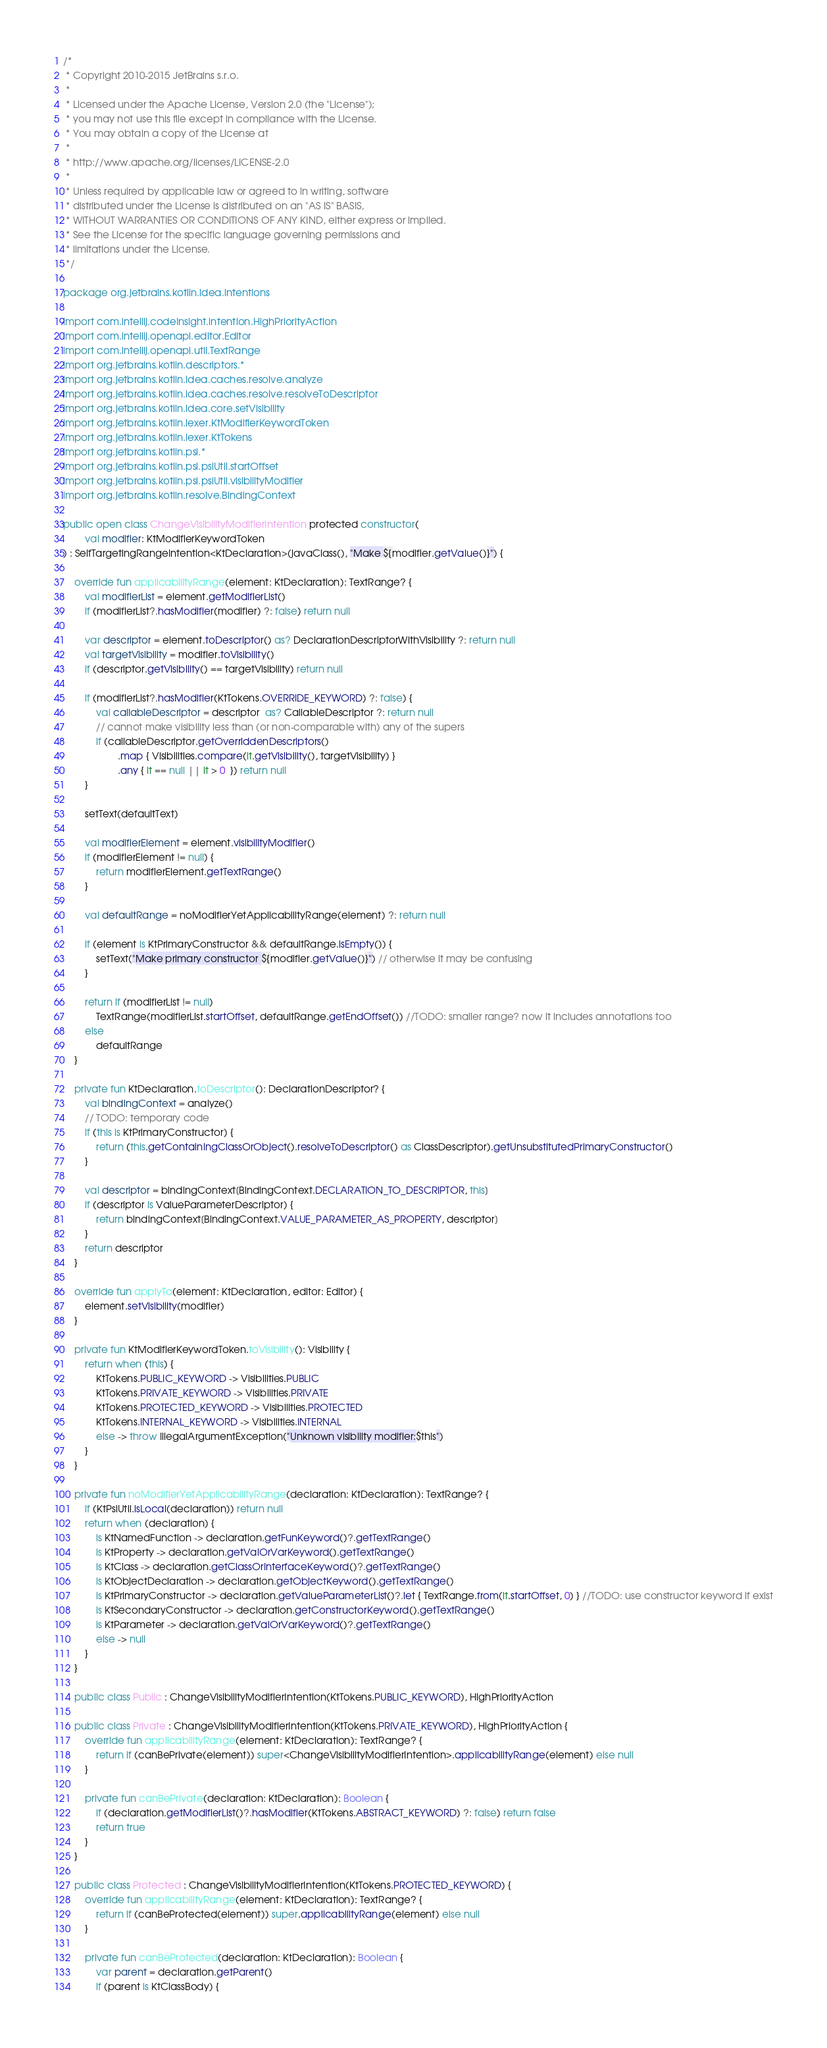Convert code to text. <code><loc_0><loc_0><loc_500><loc_500><_Kotlin_>/*
 * Copyright 2010-2015 JetBrains s.r.o.
 *
 * Licensed under the Apache License, Version 2.0 (the "License");
 * you may not use this file except in compliance with the License.
 * You may obtain a copy of the License at
 *
 * http://www.apache.org/licenses/LICENSE-2.0
 *
 * Unless required by applicable law or agreed to in writing, software
 * distributed under the License is distributed on an "AS IS" BASIS,
 * WITHOUT WARRANTIES OR CONDITIONS OF ANY KIND, either express or implied.
 * See the License for the specific language governing permissions and
 * limitations under the License.
 */

package org.jetbrains.kotlin.idea.intentions

import com.intellij.codeInsight.intention.HighPriorityAction
import com.intellij.openapi.editor.Editor
import com.intellij.openapi.util.TextRange
import org.jetbrains.kotlin.descriptors.*
import org.jetbrains.kotlin.idea.caches.resolve.analyze
import org.jetbrains.kotlin.idea.caches.resolve.resolveToDescriptor
import org.jetbrains.kotlin.idea.core.setVisibility
import org.jetbrains.kotlin.lexer.KtModifierKeywordToken
import org.jetbrains.kotlin.lexer.KtTokens
import org.jetbrains.kotlin.psi.*
import org.jetbrains.kotlin.psi.psiUtil.startOffset
import org.jetbrains.kotlin.psi.psiUtil.visibilityModifier
import org.jetbrains.kotlin.resolve.BindingContext

public open class ChangeVisibilityModifierIntention protected constructor(
        val modifier: KtModifierKeywordToken
) : SelfTargetingRangeIntention<KtDeclaration>(javaClass(), "Make ${modifier.getValue()}") {

    override fun applicabilityRange(element: KtDeclaration): TextRange? {
        val modifierList = element.getModifierList()
        if (modifierList?.hasModifier(modifier) ?: false) return null

        var descriptor = element.toDescriptor() as? DeclarationDescriptorWithVisibility ?: return null
        val targetVisibility = modifier.toVisibility()
        if (descriptor.getVisibility() == targetVisibility) return null

        if (modifierList?.hasModifier(KtTokens.OVERRIDE_KEYWORD) ?: false) {
            val callableDescriptor = descriptor  as? CallableDescriptor ?: return null
            // cannot make visibility less than (or non-comparable with) any of the supers
            if (callableDescriptor.getOverriddenDescriptors()
                    .map { Visibilities.compare(it.getVisibility(), targetVisibility) }
                    .any { it == null || it > 0  }) return null
        }

        setText(defaultText)

        val modifierElement = element.visibilityModifier()
        if (modifierElement != null) {
            return modifierElement.getTextRange()
        }

        val defaultRange = noModifierYetApplicabilityRange(element) ?: return null

        if (element is KtPrimaryConstructor && defaultRange.isEmpty()) {
            setText("Make primary constructor ${modifier.getValue()}") // otherwise it may be confusing
        }

        return if (modifierList != null)
            TextRange(modifierList.startOffset, defaultRange.getEndOffset()) //TODO: smaller range? now it includes annotations too
        else
            defaultRange
    }

    private fun KtDeclaration.toDescriptor(): DeclarationDescriptor? {
        val bindingContext = analyze()
        // TODO: temporary code
        if (this is KtPrimaryConstructor) {
            return (this.getContainingClassOrObject().resolveToDescriptor() as ClassDescriptor).getUnsubstitutedPrimaryConstructor()
        }

        val descriptor = bindingContext[BindingContext.DECLARATION_TO_DESCRIPTOR, this]
        if (descriptor is ValueParameterDescriptor) {
            return bindingContext[BindingContext.VALUE_PARAMETER_AS_PROPERTY, descriptor]
        }
        return descriptor
    }

    override fun applyTo(element: KtDeclaration, editor: Editor) {
        element.setVisibility(modifier)
    }

    private fun KtModifierKeywordToken.toVisibility(): Visibility {
        return when (this) {
            KtTokens.PUBLIC_KEYWORD -> Visibilities.PUBLIC
            KtTokens.PRIVATE_KEYWORD -> Visibilities.PRIVATE
            KtTokens.PROTECTED_KEYWORD -> Visibilities.PROTECTED
            KtTokens.INTERNAL_KEYWORD -> Visibilities.INTERNAL
            else -> throw IllegalArgumentException("Unknown visibility modifier:$this")
        }
    }

    private fun noModifierYetApplicabilityRange(declaration: KtDeclaration): TextRange? {
        if (KtPsiUtil.isLocal(declaration)) return null
        return when (declaration) {
            is KtNamedFunction -> declaration.getFunKeyword()?.getTextRange()
            is KtProperty -> declaration.getValOrVarKeyword().getTextRange()
            is KtClass -> declaration.getClassOrInterfaceKeyword()?.getTextRange()
            is KtObjectDeclaration -> declaration.getObjectKeyword().getTextRange()
            is KtPrimaryConstructor -> declaration.getValueParameterList()?.let { TextRange.from(it.startOffset, 0) } //TODO: use constructor keyword if exist
            is KtSecondaryConstructor -> declaration.getConstructorKeyword().getTextRange()
            is KtParameter -> declaration.getValOrVarKeyword()?.getTextRange()
            else -> null
        }
    }

    public class Public : ChangeVisibilityModifierIntention(KtTokens.PUBLIC_KEYWORD), HighPriorityAction

    public class Private : ChangeVisibilityModifierIntention(KtTokens.PRIVATE_KEYWORD), HighPriorityAction {
        override fun applicabilityRange(element: KtDeclaration): TextRange? {
            return if (canBePrivate(element)) super<ChangeVisibilityModifierIntention>.applicabilityRange(element) else null
        }

        private fun canBePrivate(declaration: KtDeclaration): Boolean {
            if (declaration.getModifierList()?.hasModifier(KtTokens.ABSTRACT_KEYWORD) ?: false) return false
            return true
        }
    }

    public class Protected : ChangeVisibilityModifierIntention(KtTokens.PROTECTED_KEYWORD) {
        override fun applicabilityRange(element: KtDeclaration): TextRange? {
            return if (canBeProtected(element)) super.applicabilityRange(element) else null
        }

        private fun canBeProtected(declaration: KtDeclaration): Boolean {
            var parent = declaration.getParent()
            if (parent is KtClassBody) {</code> 